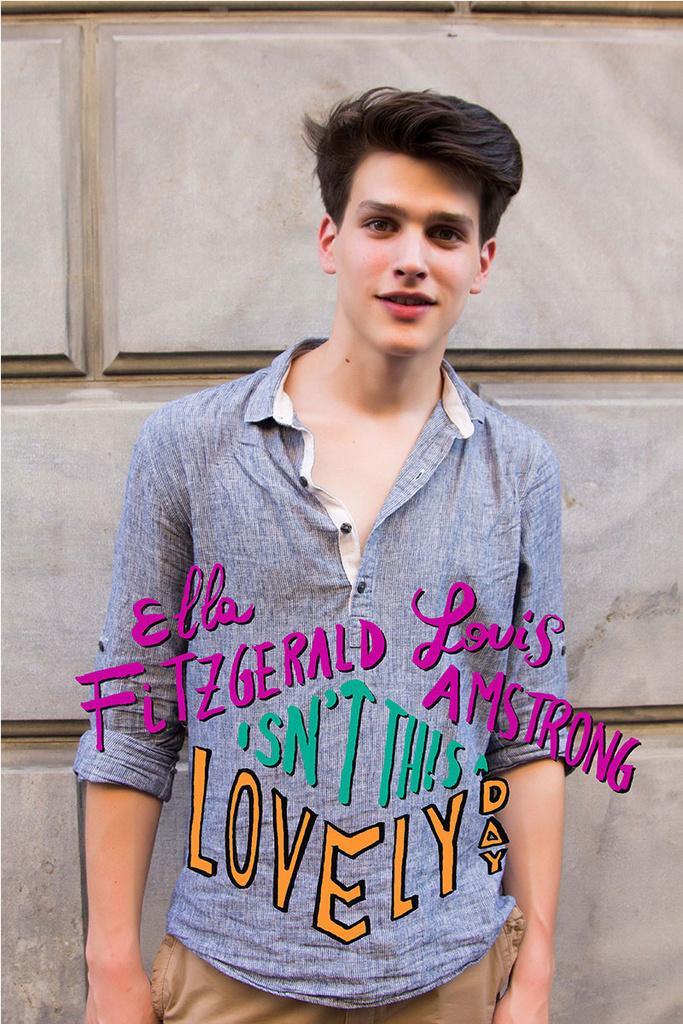Can you describe this image briefly? In the center of the image there is a man. In the background of the image there is wall. There is some text in the center of the image. 